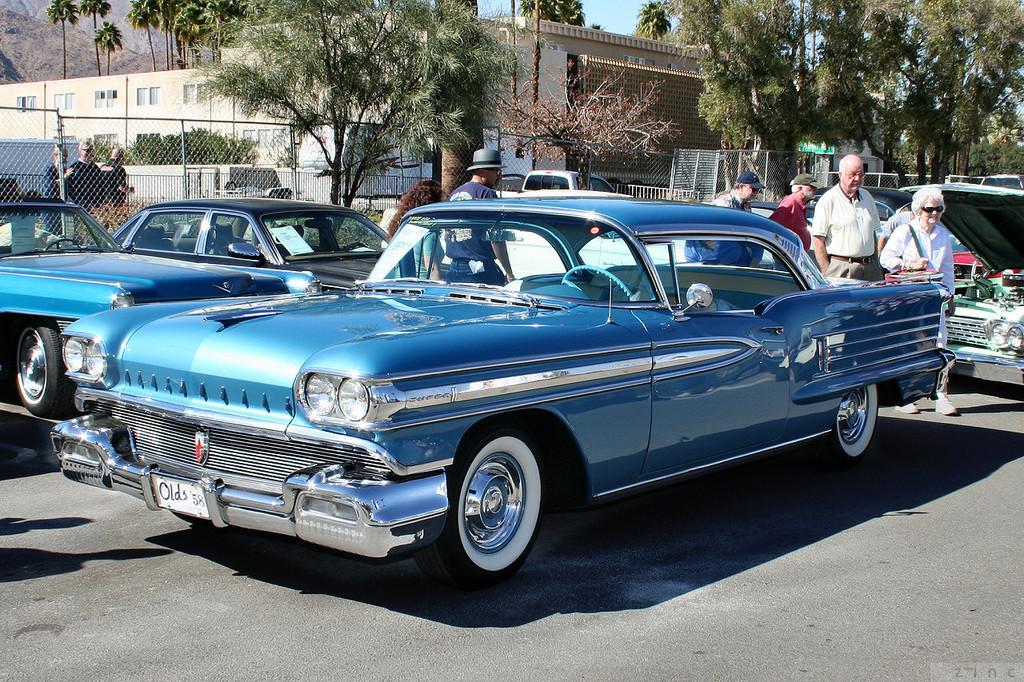What can be seen in the image related to transportation? Cars are parked in the image. Are there any people visible in the image? Yes, people are present behind the parked cars. Can you describe the girl's location in the image? There is a girl on the left side of the image. What can be seen in the background of the image? There is a building and trees in the background of the image. How many cans of paint are used to create the disease-free environment in the image? There is no mention of paint or disease in the image, so it is not possible to answer this question. 